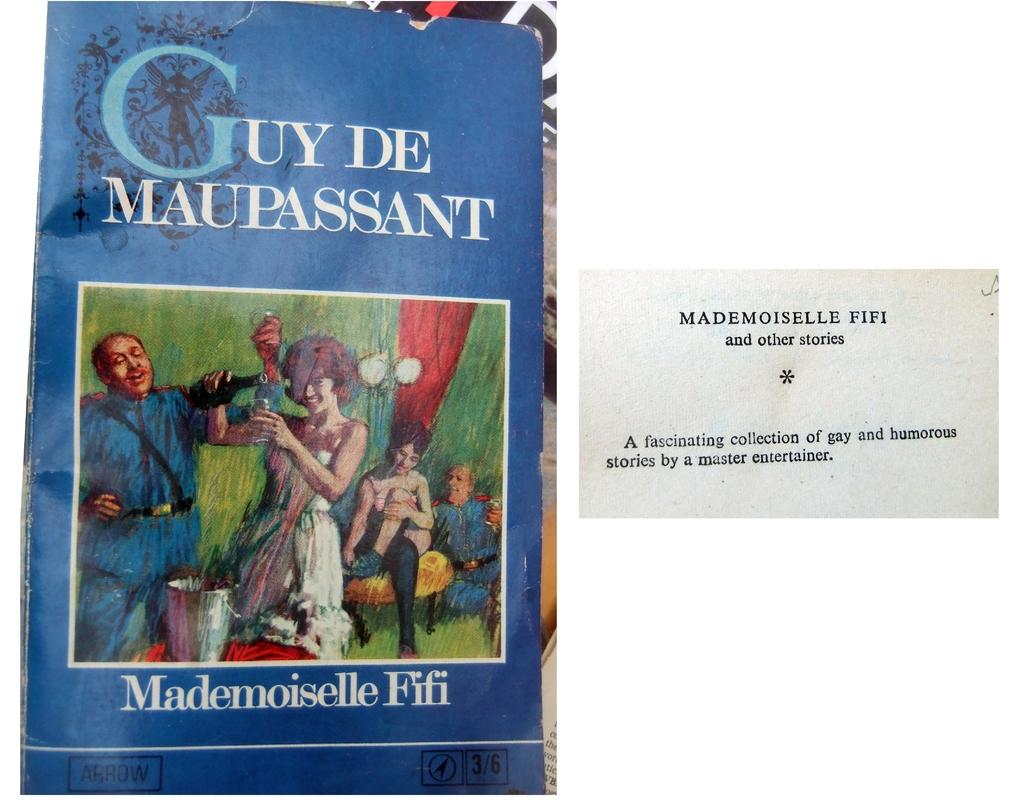What is the name of the book?
Your answer should be compact. Guy de maupassant. Who wrote the book?
Your response must be concise. Mademoiselle fifi. 